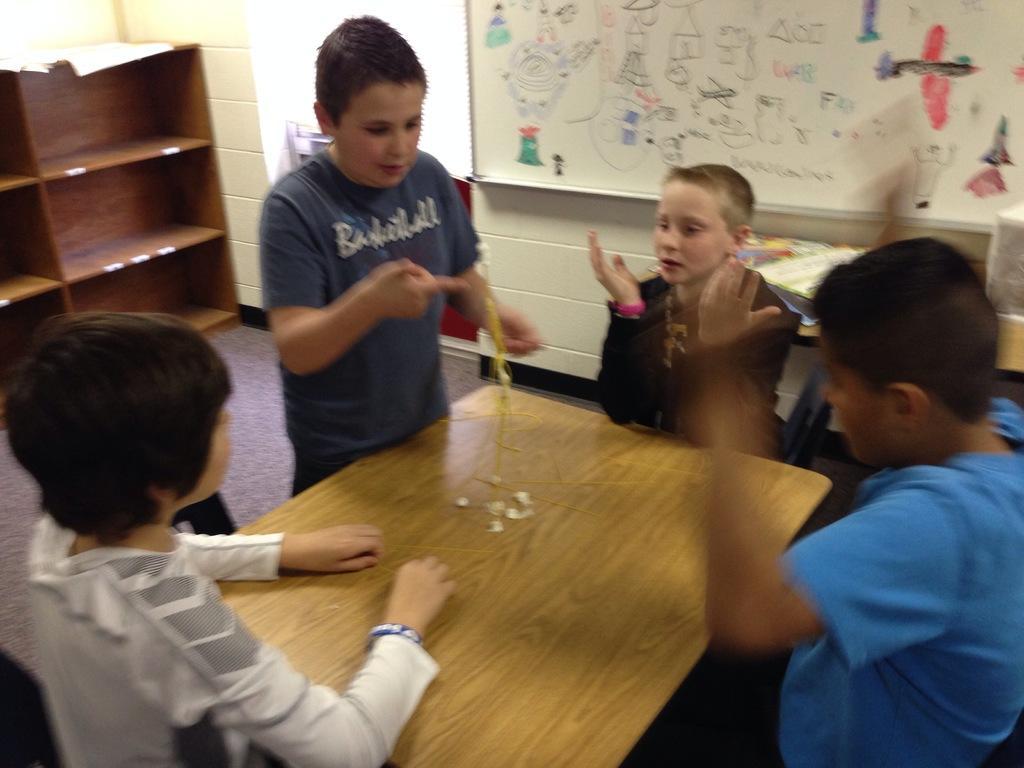Could you give a brief overview of what you see in this image? In the picture I can see four kids among them one standing and others are sitting. Here I can see a wooden table which has some objects. In the background I can see a white color board attached to the wall, a wooden shelf and some other objects on the floor. 